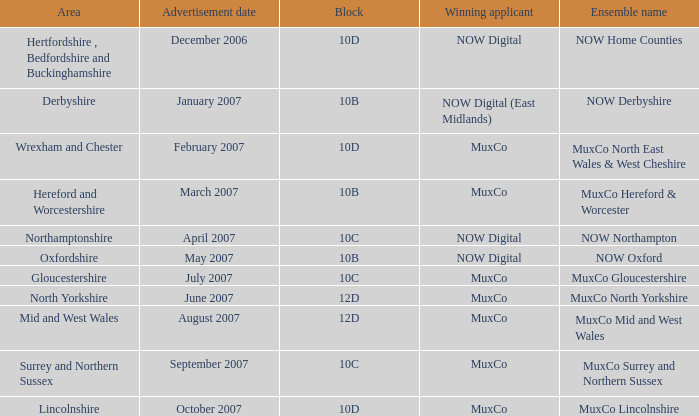Who is the successful contender for block 10b in the derbyshire zone? NOW Digital (East Midlands). 